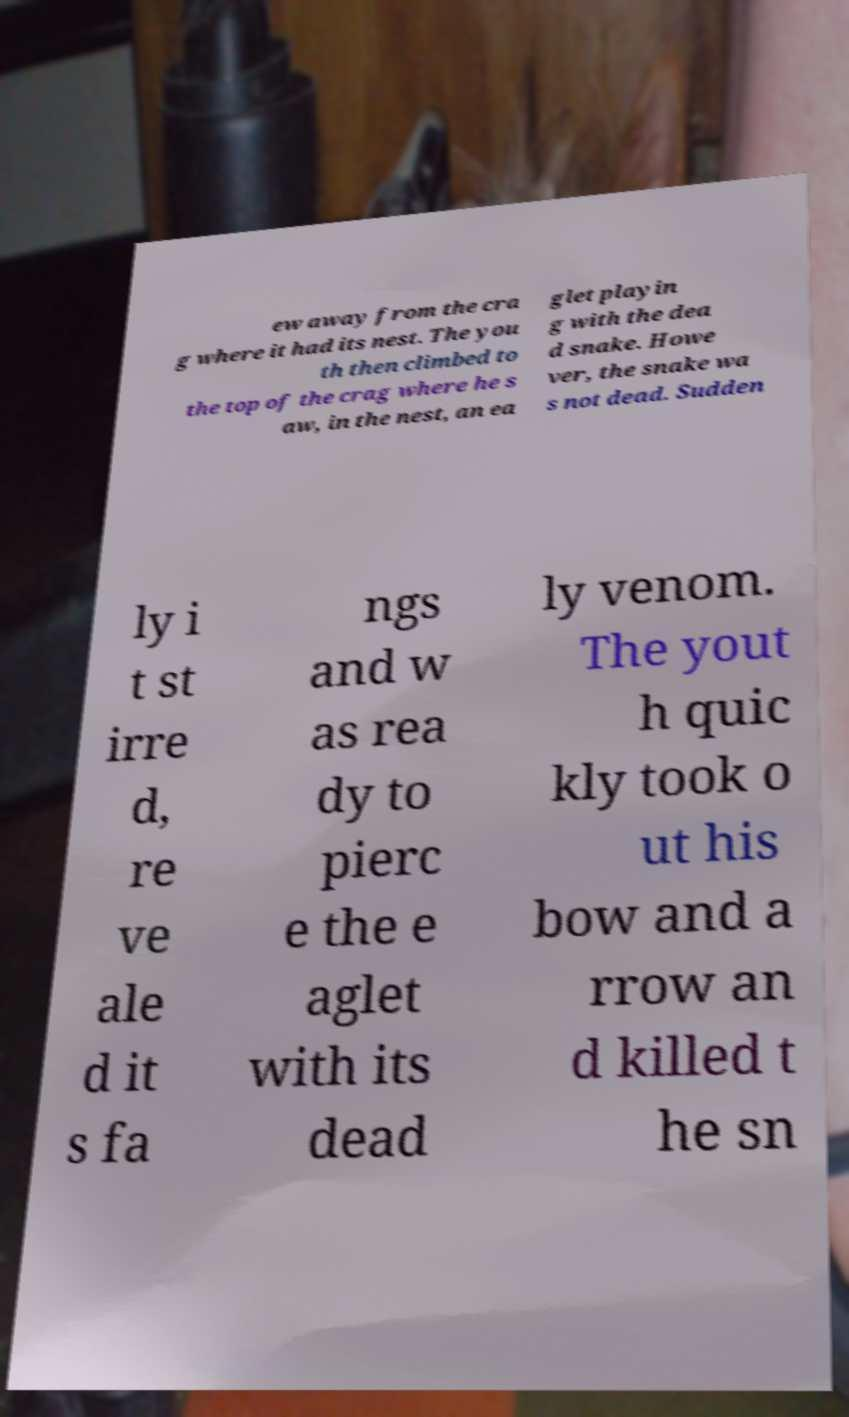Could you assist in decoding the text presented in this image and type it out clearly? ew away from the cra g where it had its nest. The you th then climbed to the top of the crag where he s aw, in the nest, an ea glet playin g with the dea d snake. Howe ver, the snake wa s not dead. Sudden ly i t st irre d, re ve ale d it s fa ngs and w as rea dy to pierc e the e aglet with its dead ly venom. The yout h quic kly took o ut his bow and a rrow an d killed t he sn 